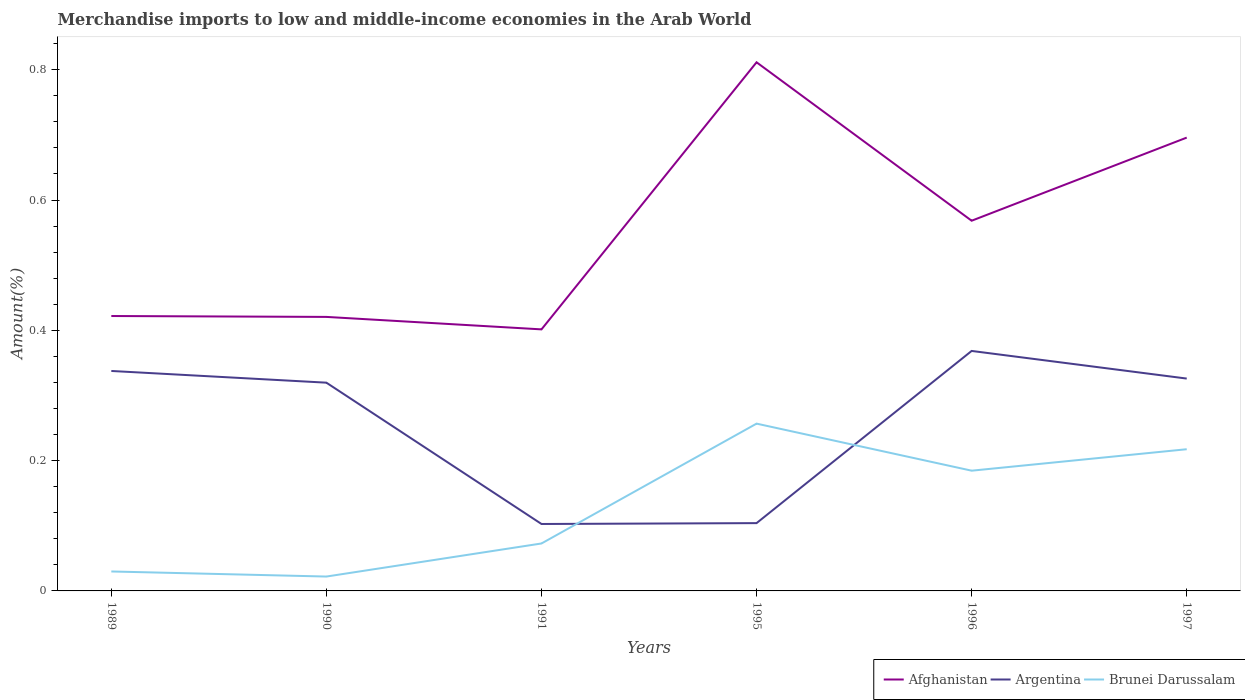How many different coloured lines are there?
Ensure brevity in your answer.  3. Across all years, what is the maximum percentage of amount earned from merchandise imports in Argentina?
Offer a very short reply. 0.1. In which year was the percentage of amount earned from merchandise imports in Brunei Darussalam maximum?
Your answer should be very brief. 1990. What is the total percentage of amount earned from merchandise imports in Argentina in the graph?
Offer a terse response. -0.03. What is the difference between the highest and the second highest percentage of amount earned from merchandise imports in Argentina?
Provide a succinct answer. 0.27. Is the percentage of amount earned from merchandise imports in Brunei Darussalam strictly greater than the percentage of amount earned from merchandise imports in Argentina over the years?
Give a very brief answer. No. How many lines are there?
Your answer should be very brief. 3. What is the difference between two consecutive major ticks on the Y-axis?
Provide a succinct answer. 0.2. Are the values on the major ticks of Y-axis written in scientific E-notation?
Your answer should be compact. No. Where does the legend appear in the graph?
Make the answer very short. Bottom right. How are the legend labels stacked?
Provide a short and direct response. Horizontal. What is the title of the graph?
Provide a short and direct response. Merchandise imports to low and middle-income economies in the Arab World. Does "Europe(all income levels)" appear as one of the legend labels in the graph?
Provide a succinct answer. No. What is the label or title of the Y-axis?
Your answer should be compact. Amount(%). What is the Amount(%) of Afghanistan in 1989?
Provide a short and direct response. 0.42. What is the Amount(%) of Argentina in 1989?
Provide a short and direct response. 0.34. What is the Amount(%) in Brunei Darussalam in 1989?
Your answer should be very brief. 0.03. What is the Amount(%) of Afghanistan in 1990?
Your answer should be very brief. 0.42. What is the Amount(%) of Argentina in 1990?
Provide a succinct answer. 0.32. What is the Amount(%) of Brunei Darussalam in 1990?
Make the answer very short. 0.02. What is the Amount(%) of Afghanistan in 1991?
Keep it short and to the point. 0.4. What is the Amount(%) in Argentina in 1991?
Ensure brevity in your answer.  0.1. What is the Amount(%) in Brunei Darussalam in 1991?
Provide a succinct answer. 0.07. What is the Amount(%) in Afghanistan in 1995?
Make the answer very short. 0.81. What is the Amount(%) in Argentina in 1995?
Provide a succinct answer. 0.1. What is the Amount(%) of Brunei Darussalam in 1995?
Your answer should be compact. 0.26. What is the Amount(%) of Afghanistan in 1996?
Offer a very short reply. 0.57. What is the Amount(%) of Argentina in 1996?
Provide a succinct answer. 0.37. What is the Amount(%) of Brunei Darussalam in 1996?
Your response must be concise. 0.18. What is the Amount(%) of Afghanistan in 1997?
Provide a short and direct response. 0.7. What is the Amount(%) in Argentina in 1997?
Provide a short and direct response. 0.33. What is the Amount(%) of Brunei Darussalam in 1997?
Give a very brief answer. 0.22. Across all years, what is the maximum Amount(%) in Afghanistan?
Offer a very short reply. 0.81. Across all years, what is the maximum Amount(%) in Argentina?
Ensure brevity in your answer.  0.37. Across all years, what is the maximum Amount(%) of Brunei Darussalam?
Your answer should be very brief. 0.26. Across all years, what is the minimum Amount(%) of Afghanistan?
Offer a terse response. 0.4. Across all years, what is the minimum Amount(%) in Argentina?
Your response must be concise. 0.1. Across all years, what is the minimum Amount(%) in Brunei Darussalam?
Offer a very short reply. 0.02. What is the total Amount(%) in Afghanistan in the graph?
Your answer should be very brief. 3.32. What is the total Amount(%) in Argentina in the graph?
Keep it short and to the point. 1.56. What is the total Amount(%) in Brunei Darussalam in the graph?
Offer a terse response. 0.78. What is the difference between the Amount(%) in Afghanistan in 1989 and that in 1990?
Make the answer very short. 0. What is the difference between the Amount(%) of Argentina in 1989 and that in 1990?
Make the answer very short. 0.02. What is the difference between the Amount(%) of Brunei Darussalam in 1989 and that in 1990?
Give a very brief answer. 0.01. What is the difference between the Amount(%) in Afghanistan in 1989 and that in 1991?
Your response must be concise. 0.02. What is the difference between the Amount(%) in Argentina in 1989 and that in 1991?
Give a very brief answer. 0.23. What is the difference between the Amount(%) of Brunei Darussalam in 1989 and that in 1991?
Ensure brevity in your answer.  -0.04. What is the difference between the Amount(%) in Afghanistan in 1989 and that in 1995?
Keep it short and to the point. -0.39. What is the difference between the Amount(%) in Argentina in 1989 and that in 1995?
Ensure brevity in your answer.  0.23. What is the difference between the Amount(%) in Brunei Darussalam in 1989 and that in 1995?
Keep it short and to the point. -0.23. What is the difference between the Amount(%) of Afghanistan in 1989 and that in 1996?
Your answer should be compact. -0.15. What is the difference between the Amount(%) in Argentina in 1989 and that in 1996?
Your answer should be compact. -0.03. What is the difference between the Amount(%) in Brunei Darussalam in 1989 and that in 1996?
Your answer should be compact. -0.15. What is the difference between the Amount(%) of Afghanistan in 1989 and that in 1997?
Your response must be concise. -0.27. What is the difference between the Amount(%) in Argentina in 1989 and that in 1997?
Your answer should be compact. 0.01. What is the difference between the Amount(%) of Brunei Darussalam in 1989 and that in 1997?
Make the answer very short. -0.19. What is the difference between the Amount(%) of Afghanistan in 1990 and that in 1991?
Ensure brevity in your answer.  0.02. What is the difference between the Amount(%) of Argentina in 1990 and that in 1991?
Your answer should be compact. 0.22. What is the difference between the Amount(%) in Brunei Darussalam in 1990 and that in 1991?
Offer a terse response. -0.05. What is the difference between the Amount(%) in Afghanistan in 1990 and that in 1995?
Offer a very short reply. -0.39. What is the difference between the Amount(%) in Argentina in 1990 and that in 1995?
Give a very brief answer. 0.22. What is the difference between the Amount(%) in Brunei Darussalam in 1990 and that in 1995?
Your response must be concise. -0.23. What is the difference between the Amount(%) of Afghanistan in 1990 and that in 1996?
Your answer should be very brief. -0.15. What is the difference between the Amount(%) in Argentina in 1990 and that in 1996?
Give a very brief answer. -0.05. What is the difference between the Amount(%) of Brunei Darussalam in 1990 and that in 1996?
Provide a short and direct response. -0.16. What is the difference between the Amount(%) in Afghanistan in 1990 and that in 1997?
Keep it short and to the point. -0.28. What is the difference between the Amount(%) in Argentina in 1990 and that in 1997?
Ensure brevity in your answer.  -0.01. What is the difference between the Amount(%) of Brunei Darussalam in 1990 and that in 1997?
Provide a succinct answer. -0.2. What is the difference between the Amount(%) in Afghanistan in 1991 and that in 1995?
Provide a succinct answer. -0.41. What is the difference between the Amount(%) in Argentina in 1991 and that in 1995?
Your answer should be compact. -0. What is the difference between the Amount(%) of Brunei Darussalam in 1991 and that in 1995?
Provide a short and direct response. -0.18. What is the difference between the Amount(%) of Afghanistan in 1991 and that in 1996?
Your answer should be very brief. -0.17. What is the difference between the Amount(%) of Argentina in 1991 and that in 1996?
Make the answer very short. -0.27. What is the difference between the Amount(%) of Brunei Darussalam in 1991 and that in 1996?
Offer a very short reply. -0.11. What is the difference between the Amount(%) of Afghanistan in 1991 and that in 1997?
Your response must be concise. -0.29. What is the difference between the Amount(%) in Argentina in 1991 and that in 1997?
Make the answer very short. -0.22. What is the difference between the Amount(%) in Brunei Darussalam in 1991 and that in 1997?
Keep it short and to the point. -0.14. What is the difference between the Amount(%) of Afghanistan in 1995 and that in 1996?
Your answer should be very brief. 0.24. What is the difference between the Amount(%) in Argentina in 1995 and that in 1996?
Keep it short and to the point. -0.26. What is the difference between the Amount(%) in Brunei Darussalam in 1995 and that in 1996?
Provide a short and direct response. 0.07. What is the difference between the Amount(%) in Afghanistan in 1995 and that in 1997?
Give a very brief answer. 0.12. What is the difference between the Amount(%) in Argentina in 1995 and that in 1997?
Your response must be concise. -0.22. What is the difference between the Amount(%) in Brunei Darussalam in 1995 and that in 1997?
Provide a succinct answer. 0.04. What is the difference between the Amount(%) in Afghanistan in 1996 and that in 1997?
Ensure brevity in your answer.  -0.13. What is the difference between the Amount(%) in Argentina in 1996 and that in 1997?
Your answer should be very brief. 0.04. What is the difference between the Amount(%) in Brunei Darussalam in 1996 and that in 1997?
Your answer should be very brief. -0.03. What is the difference between the Amount(%) of Afghanistan in 1989 and the Amount(%) of Argentina in 1990?
Ensure brevity in your answer.  0.1. What is the difference between the Amount(%) in Afghanistan in 1989 and the Amount(%) in Brunei Darussalam in 1990?
Give a very brief answer. 0.4. What is the difference between the Amount(%) of Argentina in 1989 and the Amount(%) of Brunei Darussalam in 1990?
Ensure brevity in your answer.  0.32. What is the difference between the Amount(%) of Afghanistan in 1989 and the Amount(%) of Argentina in 1991?
Your answer should be very brief. 0.32. What is the difference between the Amount(%) of Afghanistan in 1989 and the Amount(%) of Brunei Darussalam in 1991?
Make the answer very short. 0.35. What is the difference between the Amount(%) in Argentina in 1989 and the Amount(%) in Brunei Darussalam in 1991?
Make the answer very short. 0.26. What is the difference between the Amount(%) in Afghanistan in 1989 and the Amount(%) in Argentina in 1995?
Offer a terse response. 0.32. What is the difference between the Amount(%) of Afghanistan in 1989 and the Amount(%) of Brunei Darussalam in 1995?
Provide a short and direct response. 0.17. What is the difference between the Amount(%) of Argentina in 1989 and the Amount(%) of Brunei Darussalam in 1995?
Give a very brief answer. 0.08. What is the difference between the Amount(%) in Afghanistan in 1989 and the Amount(%) in Argentina in 1996?
Give a very brief answer. 0.05. What is the difference between the Amount(%) of Afghanistan in 1989 and the Amount(%) of Brunei Darussalam in 1996?
Keep it short and to the point. 0.24. What is the difference between the Amount(%) of Argentina in 1989 and the Amount(%) of Brunei Darussalam in 1996?
Provide a succinct answer. 0.15. What is the difference between the Amount(%) in Afghanistan in 1989 and the Amount(%) in Argentina in 1997?
Keep it short and to the point. 0.1. What is the difference between the Amount(%) of Afghanistan in 1989 and the Amount(%) of Brunei Darussalam in 1997?
Offer a very short reply. 0.2. What is the difference between the Amount(%) in Argentina in 1989 and the Amount(%) in Brunei Darussalam in 1997?
Make the answer very short. 0.12. What is the difference between the Amount(%) in Afghanistan in 1990 and the Amount(%) in Argentina in 1991?
Give a very brief answer. 0.32. What is the difference between the Amount(%) of Afghanistan in 1990 and the Amount(%) of Brunei Darussalam in 1991?
Your answer should be compact. 0.35. What is the difference between the Amount(%) of Argentina in 1990 and the Amount(%) of Brunei Darussalam in 1991?
Make the answer very short. 0.25. What is the difference between the Amount(%) in Afghanistan in 1990 and the Amount(%) in Argentina in 1995?
Provide a succinct answer. 0.32. What is the difference between the Amount(%) of Afghanistan in 1990 and the Amount(%) of Brunei Darussalam in 1995?
Give a very brief answer. 0.16. What is the difference between the Amount(%) in Argentina in 1990 and the Amount(%) in Brunei Darussalam in 1995?
Keep it short and to the point. 0.06. What is the difference between the Amount(%) of Afghanistan in 1990 and the Amount(%) of Argentina in 1996?
Ensure brevity in your answer.  0.05. What is the difference between the Amount(%) of Afghanistan in 1990 and the Amount(%) of Brunei Darussalam in 1996?
Offer a very short reply. 0.24. What is the difference between the Amount(%) in Argentina in 1990 and the Amount(%) in Brunei Darussalam in 1996?
Make the answer very short. 0.14. What is the difference between the Amount(%) in Afghanistan in 1990 and the Amount(%) in Argentina in 1997?
Give a very brief answer. 0.09. What is the difference between the Amount(%) of Afghanistan in 1990 and the Amount(%) of Brunei Darussalam in 1997?
Provide a short and direct response. 0.2. What is the difference between the Amount(%) of Argentina in 1990 and the Amount(%) of Brunei Darussalam in 1997?
Give a very brief answer. 0.1. What is the difference between the Amount(%) in Afghanistan in 1991 and the Amount(%) in Argentina in 1995?
Offer a terse response. 0.3. What is the difference between the Amount(%) of Afghanistan in 1991 and the Amount(%) of Brunei Darussalam in 1995?
Provide a succinct answer. 0.14. What is the difference between the Amount(%) in Argentina in 1991 and the Amount(%) in Brunei Darussalam in 1995?
Make the answer very short. -0.15. What is the difference between the Amount(%) in Afghanistan in 1991 and the Amount(%) in Argentina in 1996?
Your answer should be very brief. 0.03. What is the difference between the Amount(%) of Afghanistan in 1991 and the Amount(%) of Brunei Darussalam in 1996?
Offer a very short reply. 0.22. What is the difference between the Amount(%) in Argentina in 1991 and the Amount(%) in Brunei Darussalam in 1996?
Keep it short and to the point. -0.08. What is the difference between the Amount(%) of Afghanistan in 1991 and the Amount(%) of Argentina in 1997?
Offer a terse response. 0.08. What is the difference between the Amount(%) of Afghanistan in 1991 and the Amount(%) of Brunei Darussalam in 1997?
Ensure brevity in your answer.  0.18. What is the difference between the Amount(%) in Argentina in 1991 and the Amount(%) in Brunei Darussalam in 1997?
Your answer should be very brief. -0.11. What is the difference between the Amount(%) of Afghanistan in 1995 and the Amount(%) of Argentina in 1996?
Your response must be concise. 0.44. What is the difference between the Amount(%) of Afghanistan in 1995 and the Amount(%) of Brunei Darussalam in 1996?
Your answer should be very brief. 0.63. What is the difference between the Amount(%) in Argentina in 1995 and the Amount(%) in Brunei Darussalam in 1996?
Your answer should be compact. -0.08. What is the difference between the Amount(%) in Afghanistan in 1995 and the Amount(%) in Argentina in 1997?
Provide a short and direct response. 0.49. What is the difference between the Amount(%) in Afghanistan in 1995 and the Amount(%) in Brunei Darussalam in 1997?
Offer a very short reply. 0.59. What is the difference between the Amount(%) in Argentina in 1995 and the Amount(%) in Brunei Darussalam in 1997?
Provide a short and direct response. -0.11. What is the difference between the Amount(%) in Afghanistan in 1996 and the Amount(%) in Argentina in 1997?
Offer a terse response. 0.24. What is the difference between the Amount(%) in Afghanistan in 1996 and the Amount(%) in Brunei Darussalam in 1997?
Give a very brief answer. 0.35. What is the difference between the Amount(%) of Argentina in 1996 and the Amount(%) of Brunei Darussalam in 1997?
Offer a very short reply. 0.15. What is the average Amount(%) of Afghanistan per year?
Your answer should be very brief. 0.55. What is the average Amount(%) of Argentina per year?
Keep it short and to the point. 0.26. What is the average Amount(%) in Brunei Darussalam per year?
Provide a short and direct response. 0.13. In the year 1989, what is the difference between the Amount(%) of Afghanistan and Amount(%) of Argentina?
Ensure brevity in your answer.  0.08. In the year 1989, what is the difference between the Amount(%) of Afghanistan and Amount(%) of Brunei Darussalam?
Keep it short and to the point. 0.39. In the year 1989, what is the difference between the Amount(%) in Argentina and Amount(%) in Brunei Darussalam?
Your answer should be compact. 0.31. In the year 1990, what is the difference between the Amount(%) in Afghanistan and Amount(%) in Argentina?
Make the answer very short. 0.1. In the year 1990, what is the difference between the Amount(%) of Afghanistan and Amount(%) of Brunei Darussalam?
Ensure brevity in your answer.  0.4. In the year 1990, what is the difference between the Amount(%) of Argentina and Amount(%) of Brunei Darussalam?
Provide a short and direct response. 0.3. In the year 1991, what is the difference between the Amount(%) of Afghanistan and Amount(%) of Argentina?
Ensure brevity in your answer.  0.3. In the year 1991, what is the difference between the Amount(%) in Afghanistan and Amount(%) in Brunei Darussalam?
Offer a very short reply. 0.33. In the year 1991, what is the difference between the Amount(%) in Argentina and Amount(%) in Brunei Darussalam?
Your answer should be very brief. 0.03. In the year 1995, what is the difference between the Amount(%) in Afghanistan and Amount(%) in Argentina?
Offer a very short reply. 0.71. In the year 1995, what is the difference between the Amount(%) in Afghanistan and Amount(%) in Brunei Darussalam?
Keep it short and to the point. 0.55. In the year 1995, what is the difference between the Amount(%) of Argentina and Amount(%) of Brunei Darussalam?
Give a very brief answer. -0.15. In the year 1996, what is the difference between the Amount(%) of Afghanistan and Amount(%) of Argentina?
Your response must be concise. 0.2. In the year 1996, what is the difference between the Amount(%) in Afghanistan and Amount(%) in Brunei Darussalam?
Offer a terse response. 0.38. In the year 1996, what is the difference between the Amount(%) in Argentina and Amount(%) in Brunei Darussalam?
Provide a short and direct response. 0.18. In the year 1997, what is the difference between the Amount(%) of Afghanistan and Amount(%) of Argentina?
Ensure brevity in your answer.  0.37. In the year 1997, what is the difference between the Amount(%) in Afghanistan and Amount(%) in Brunei Darussalam?
Offer a very short reply. 0.48. In the year 1997, what is the difference between the Amount(%) of Argentina and Amount(%) of Brunei Darussalam?
Your response must be concise. 0.11. What is the ratio of the Amount(%) of Argentina in 1989 to that in 1990?
Provide a succinct answer. 1.06. What is the ratio of the Amount(%) in Brunei Darussalam in 1989 to that in 1990?
Offer a very short reply. 1.35. What is the ratio of the Amount(%) of Afghanistan in 1989 to that in 1991?
Your response must be concise. 1.05. What is the ratio of the Amount(%) of Argentina in 1989 to that in 1991?
Your response must be concise. 3.29. What is the ratio of the Amount(%) in Brunei Darussalam in 1989 to that in 1991?
Ensure brevity in your answer.  0.41. What is the ratio of the Amount(%) in Afghanistan in 1989 to that in 1995?
Keep it short and to the point. 0.52. What is the ratio of the Amount(%) in Argentina in 1989 to that in 1995?
Keep it short and to the point. 3.24. What is the ratio of the Amount(%) of Brunei Darussalam in 1989 to that in 1995?
Make the answer very short. 0.12. What is the ratio of the Amount(%) in Afghanistan in 1989 to that in 1996?
Ensure brevity in your answer.  0.74. What is the ratio of the Amount(%) in Argentina in 1989 to that in 1996?
Ensure brevity in your answer.  0.92. What is the ratio of the Amount(%) in Brunei Darussalam in 1989 to that in 1996?
Your answer should be very brief. 0.16. What is the ratio of the Amount(%) in Afghanistan in 1989 to that in 1997?
Offer a terse response. 0.61. What is the ratio of the Amount(%) in Argentina in 1989 to that in 1997?
Your answer should be very brief. 1.04. What is the ratio of the Amount(%) of Brunei Darussalam in 1989 to that in 1997?
Offer a terse response. 0.14. What is the ratio of the Amount(%) of Afghanistan in 1990 to that in 1991?
Offer a terse response. 1.05. What is the ratio of the Amount(%) in Argentina in 1990 to that in 1991?
Make the answer very short. 3.11. What is the ratio of the Amount(%) of Brunei Darussalam in 1990 to that in 1991?
Ensure brevity in your answer.  0.3. What is the ratio of the Amount(%) of Afghanistan in 1990 to that in 1995?
Offer a very short reply. 0.52. What is the ratio of the Amount(%) in Argentina in 1990 to that in 1995?
Your response must be concise. 3.07. What is the ratio of the Amount(%) of Brunei Darussalam in 1990 to that in 1995?
Offer a terse response. 0.09. What is the ratio of the Amount(%) of Afghanistan in 1990 to that in 1996?
Offer a terse response. 0.74. What is the ratio of the Amount(%) in Argentina in 1990 to that in 1996?
Your response must be concise. 0.87. What is the ratio of the Amount(%) of Brunei Darussalam in 1990 to that in 1996?
Your answer should be very brief. 0.12. What is the ratio of the Amount(%) in Afghanistan in 1990 to that in 1997?
Keep it short and to the point. 0.6. What is the ratio of the Amount(%) of Argentina in 1990 to that in 1997?
Provide a succinct answer. 0.98. What is the ratio of the Amount(%) of Brunei Darussalam in 1990 to that in 1997?
Offer a very short reply. 0.1. What is the ratio of the Amount(%) in Afghanistan in 1991 to that in 1995?
Give a very brief answer. 0.49. What is the ratio of the Amount(%) in Argentina in 1991 to that in 1995?
Offer a terse response. 0.99. What is the ratio of the Amount(%) of Brunei Darussalam in 1991 to that in 1995?
Offer a very short reply. 0.28. What is the ratio of the Amount(%) of Afghanistan in 1991 to that in 1996?
Provide a succinct answer. 0.71. What is the ratio of the Amount(%) of Argentina in 1991 to that in 1996?
Offer a terse response. 0.28. What is the ratio of the Amount(%) of Brunei Darussalam in 1991 to that in 1996?
Make the answer very short. 0.39. What is the ratio of the Amount(%) in Afghanistan in 1991 to that in 1997?
Give a very brief answer. 0.58. What is the ratio of the Amount(%) of Argentina in 1991 to that in 1997?
Your answer should be very brief. 0.32. What is the ratio of the Amount(%) in Brunei Darussalam in 1991 to that in 1997?
Make the answer very short. 0.33. What is the ratio of the Amount(%) in Afghanistan in 1995 to that in 1996?
Your response must be concise. 1.43. What is the ratio of the Amount(%) in Argentina in 1995 to that in 1996?
Your answer should be compact. 0.28. What is the ratio of the Amount(%) of Brunei Darussalam in 1995 to that in 1996?
Make the answer very short. 1.39. What is the ratio of the Amount(%) of Afghanistan in 1995 to that in 1997?
Ensure brevity in your answer.  1.17. What is the ratio of the Amount(%) in Argentina in 1995 to that in 1997?
Keep it short and to the point. 0.32. What is the ratio of the Amount(%) in Brunei Darussalam in 1995 to that in 1997?
Your response must be concise. 1.18. What is the ratio of the Amount(%) of Afghanistan in 1996 to that in 1997?
Your answer should be very brief. 0.82. What is the ratio of the Amount(%) of Argentina in 1996 to that in 1997?
Give a very brief answer. 1.13. What is the ratio of the Amount(%) in Brunei Darussalam in 1996 to that in 1997?
Give a very brief answer. 0.85. What is the difference between the highest and the second highest Amount(%) in Afghanistan?
Your answer should be compact. 0.12. What is the difference between the highest and the second highest Amount(%) of Argentina?
Offer a terse response. 0.03. What is the difference between the highest and the second highest Amount(%) in Brunei Darussalam?
Keep it short and to the point. 0.04. What is the difference between the highest and the lowest Amount(%) in Afghanistan?
Provide a short and direct response. 0.41. What is the difference between the highest and the lowest Amount(%) of Argentina?
Ensure brevity in your answer.  0.27. What is the difference between the highest and the lowest Amount(%) in Brunei Darussalam?
Your answer should be compact. 0.23. 